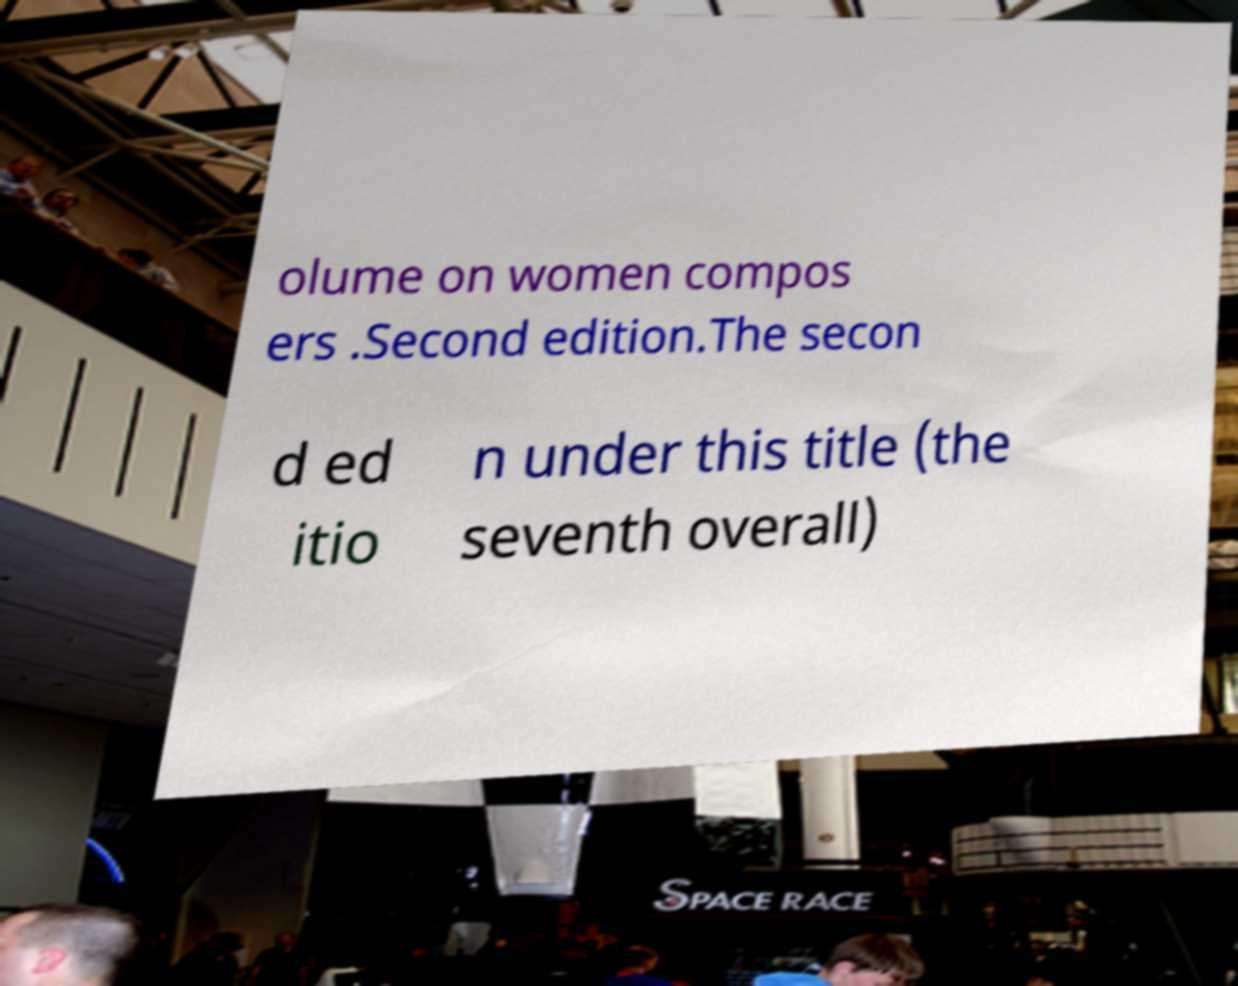Please read and relay the text visible in this image. What does it say? olume on women compos ers .Second edition.The secon d ed itio n under this title (the seventh overall) 